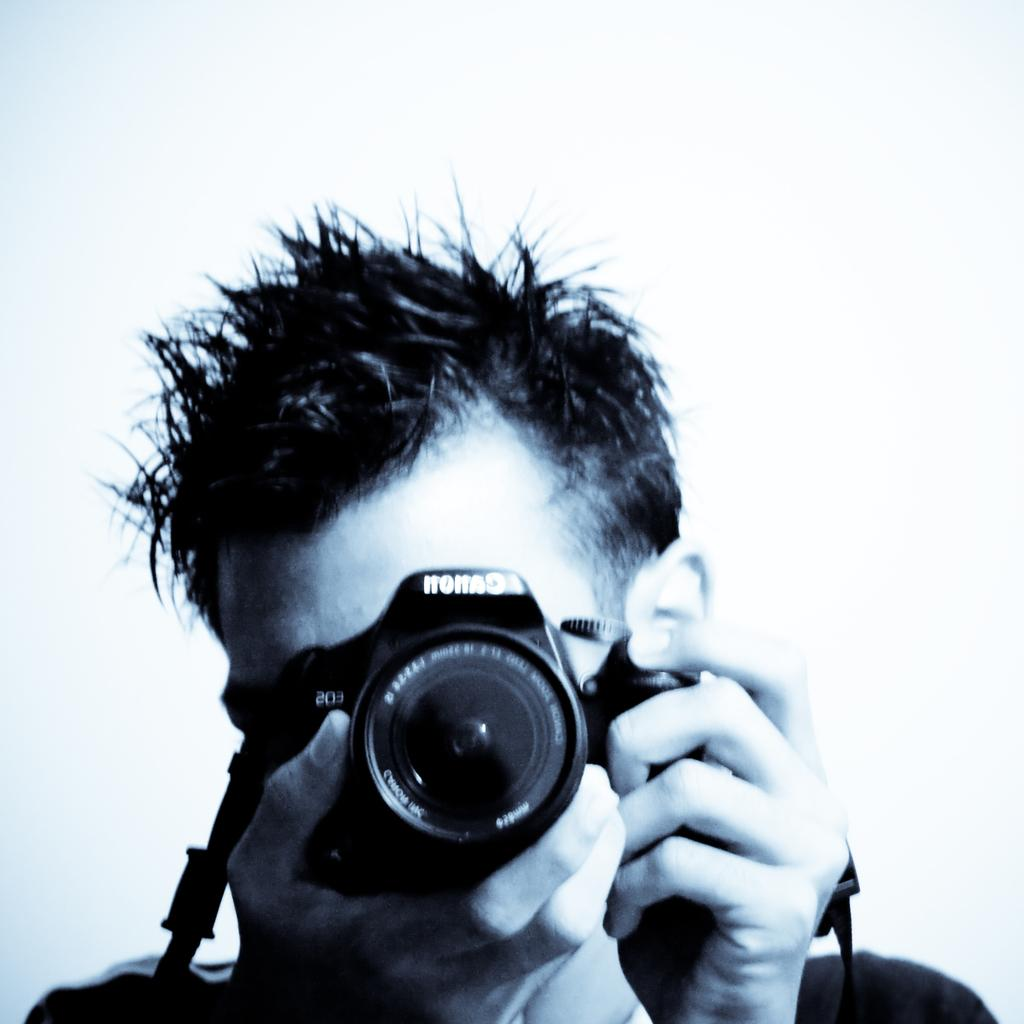What is the main subject of the image? There is a man in the image. What is the man holding in the image? The man is holding a camera. How many baseballs can be seen in the image? There are no baseballs present in the image. What type of neck accessory is the man wearing in the image? The image does not show the man wearing any neck accessory. 